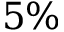<formula> <loc_0><loc_0><loc_500><loc_500>5 \%</formula> 